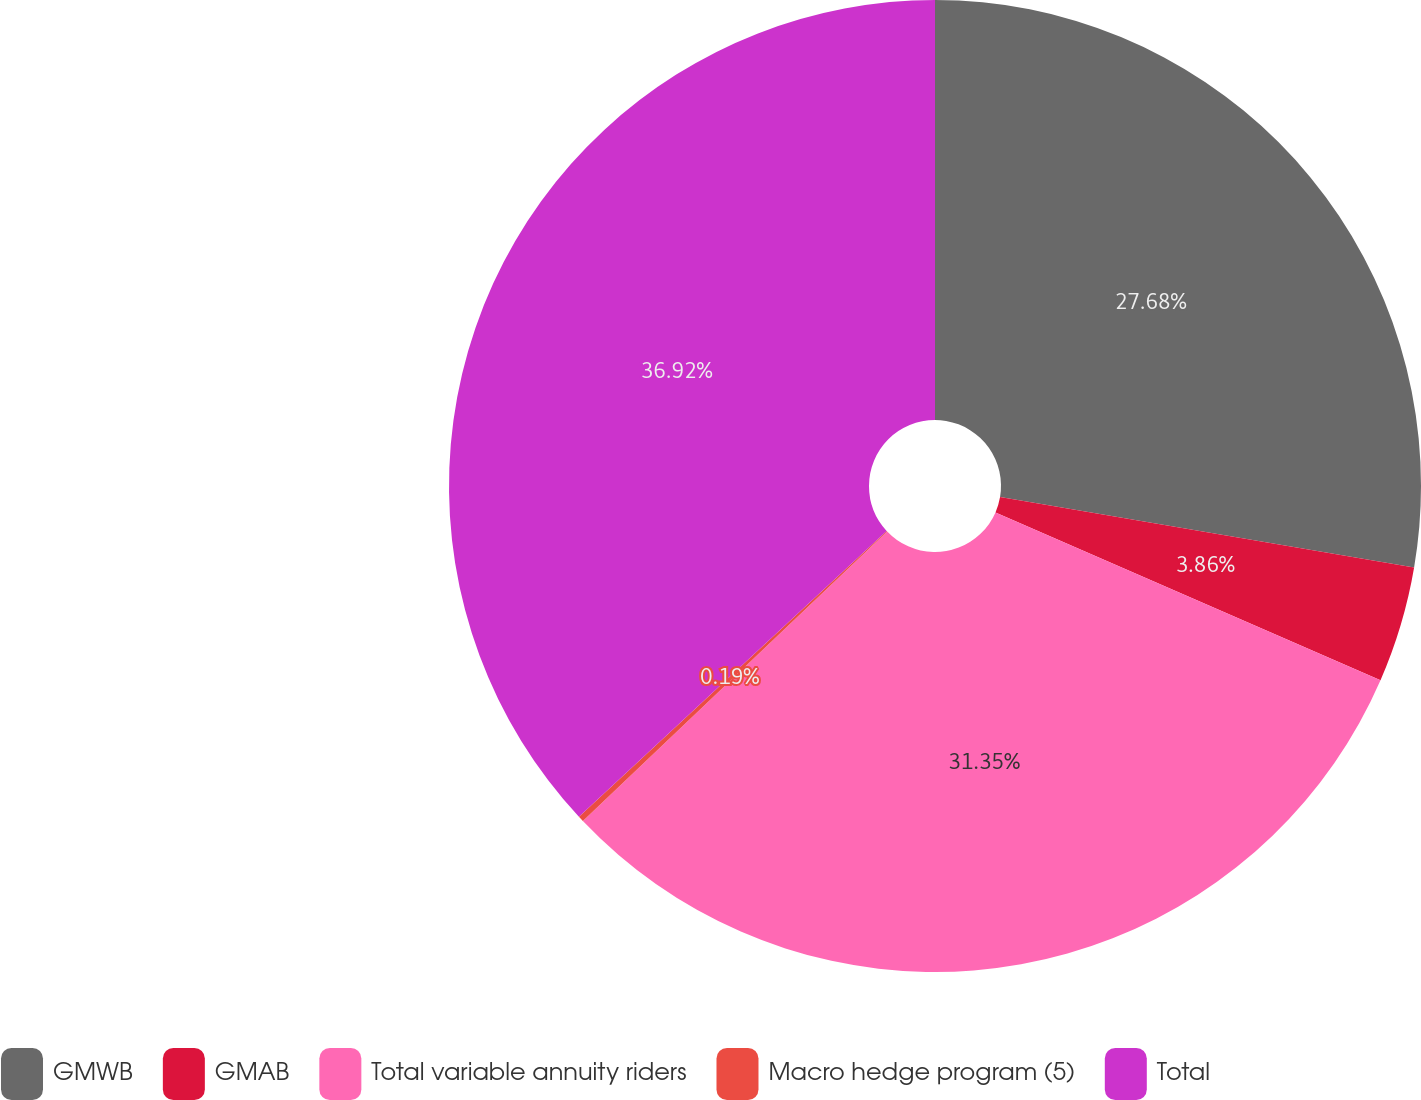Convert chart. <chart><loc_0><loc_0><loc_500><loc_500><pie_chart><fcel>GMWB<fcel>GMAB<fcel>Total variable annuity riders<fcel>Macro hedge program (5)<fcel>Total<nl><fcel>27.68%<fcel>3.86%<fcel>31.35%<fcel>0.19%<fcel>36.91%<nl></chart> 